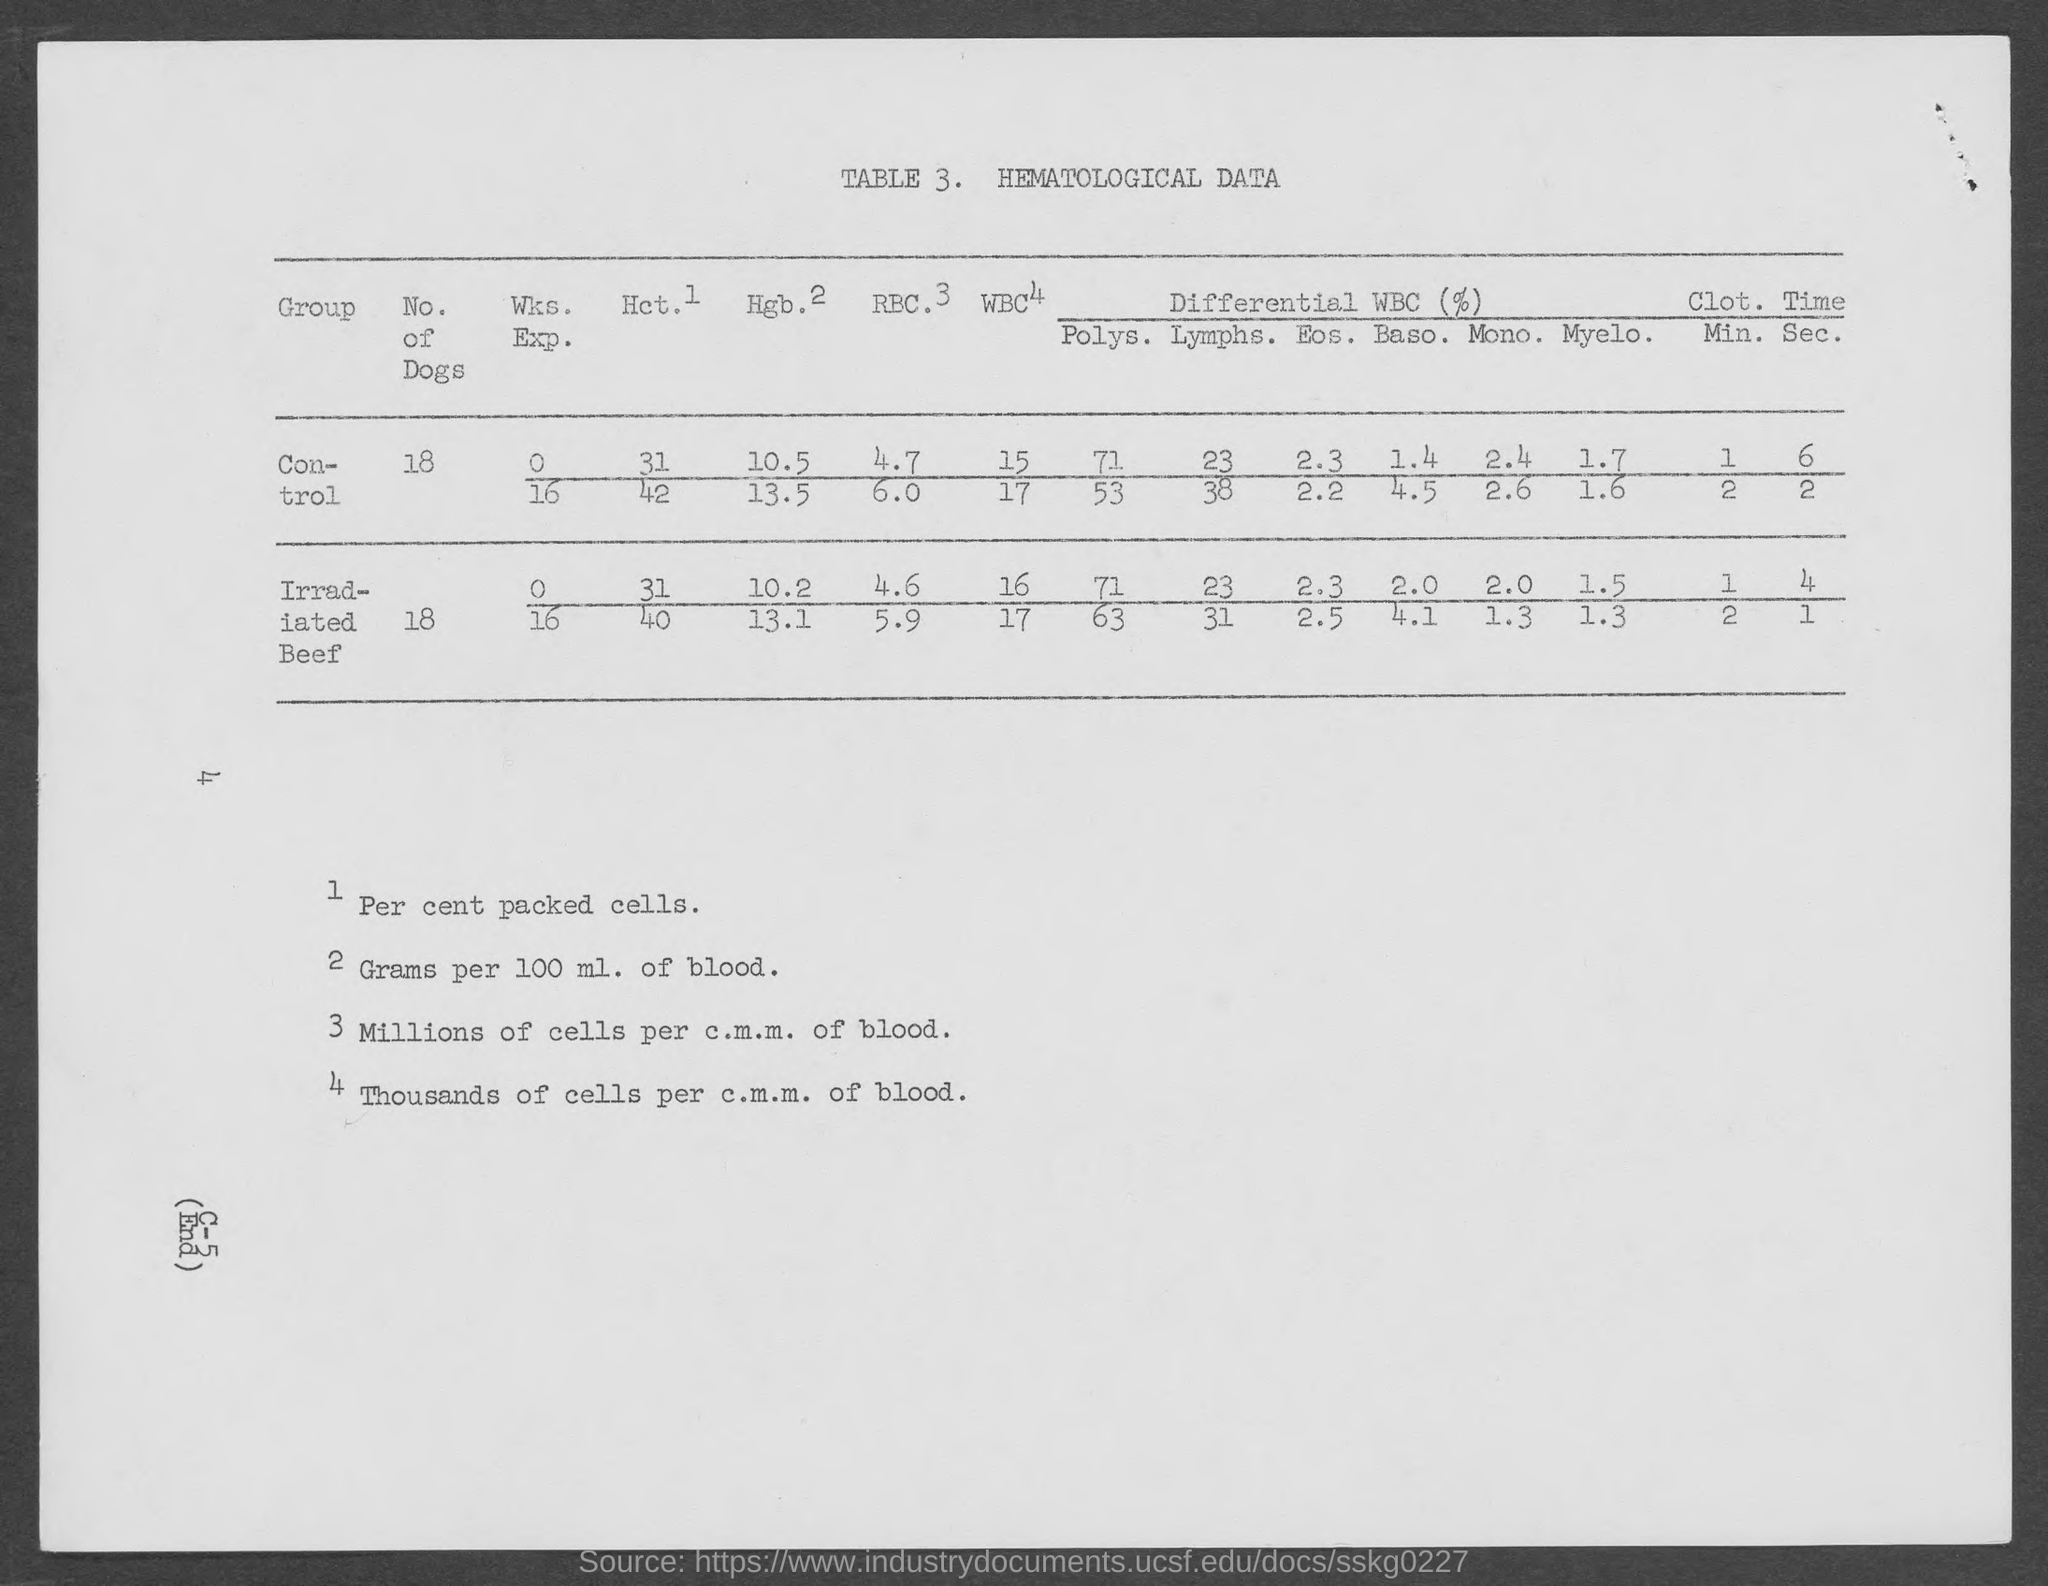What is the "Control" "No. of Dogs"?
Keep it short and to the point. 18. 